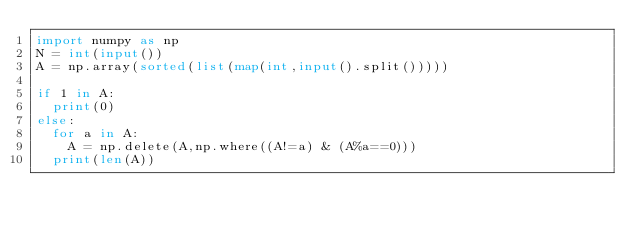<code> <loc_0><loc_0><loc_500><loc_500><_Python_>import numpy as np
N = int(input())
A = np.array(sorted(list(map(int,input().split()))))

if 1 in A:
  print(0)
else:
  for a in A:
    A = np.delete(A,np.where((A!=a) & (A%a==0)))
  print(len(A))</code> 